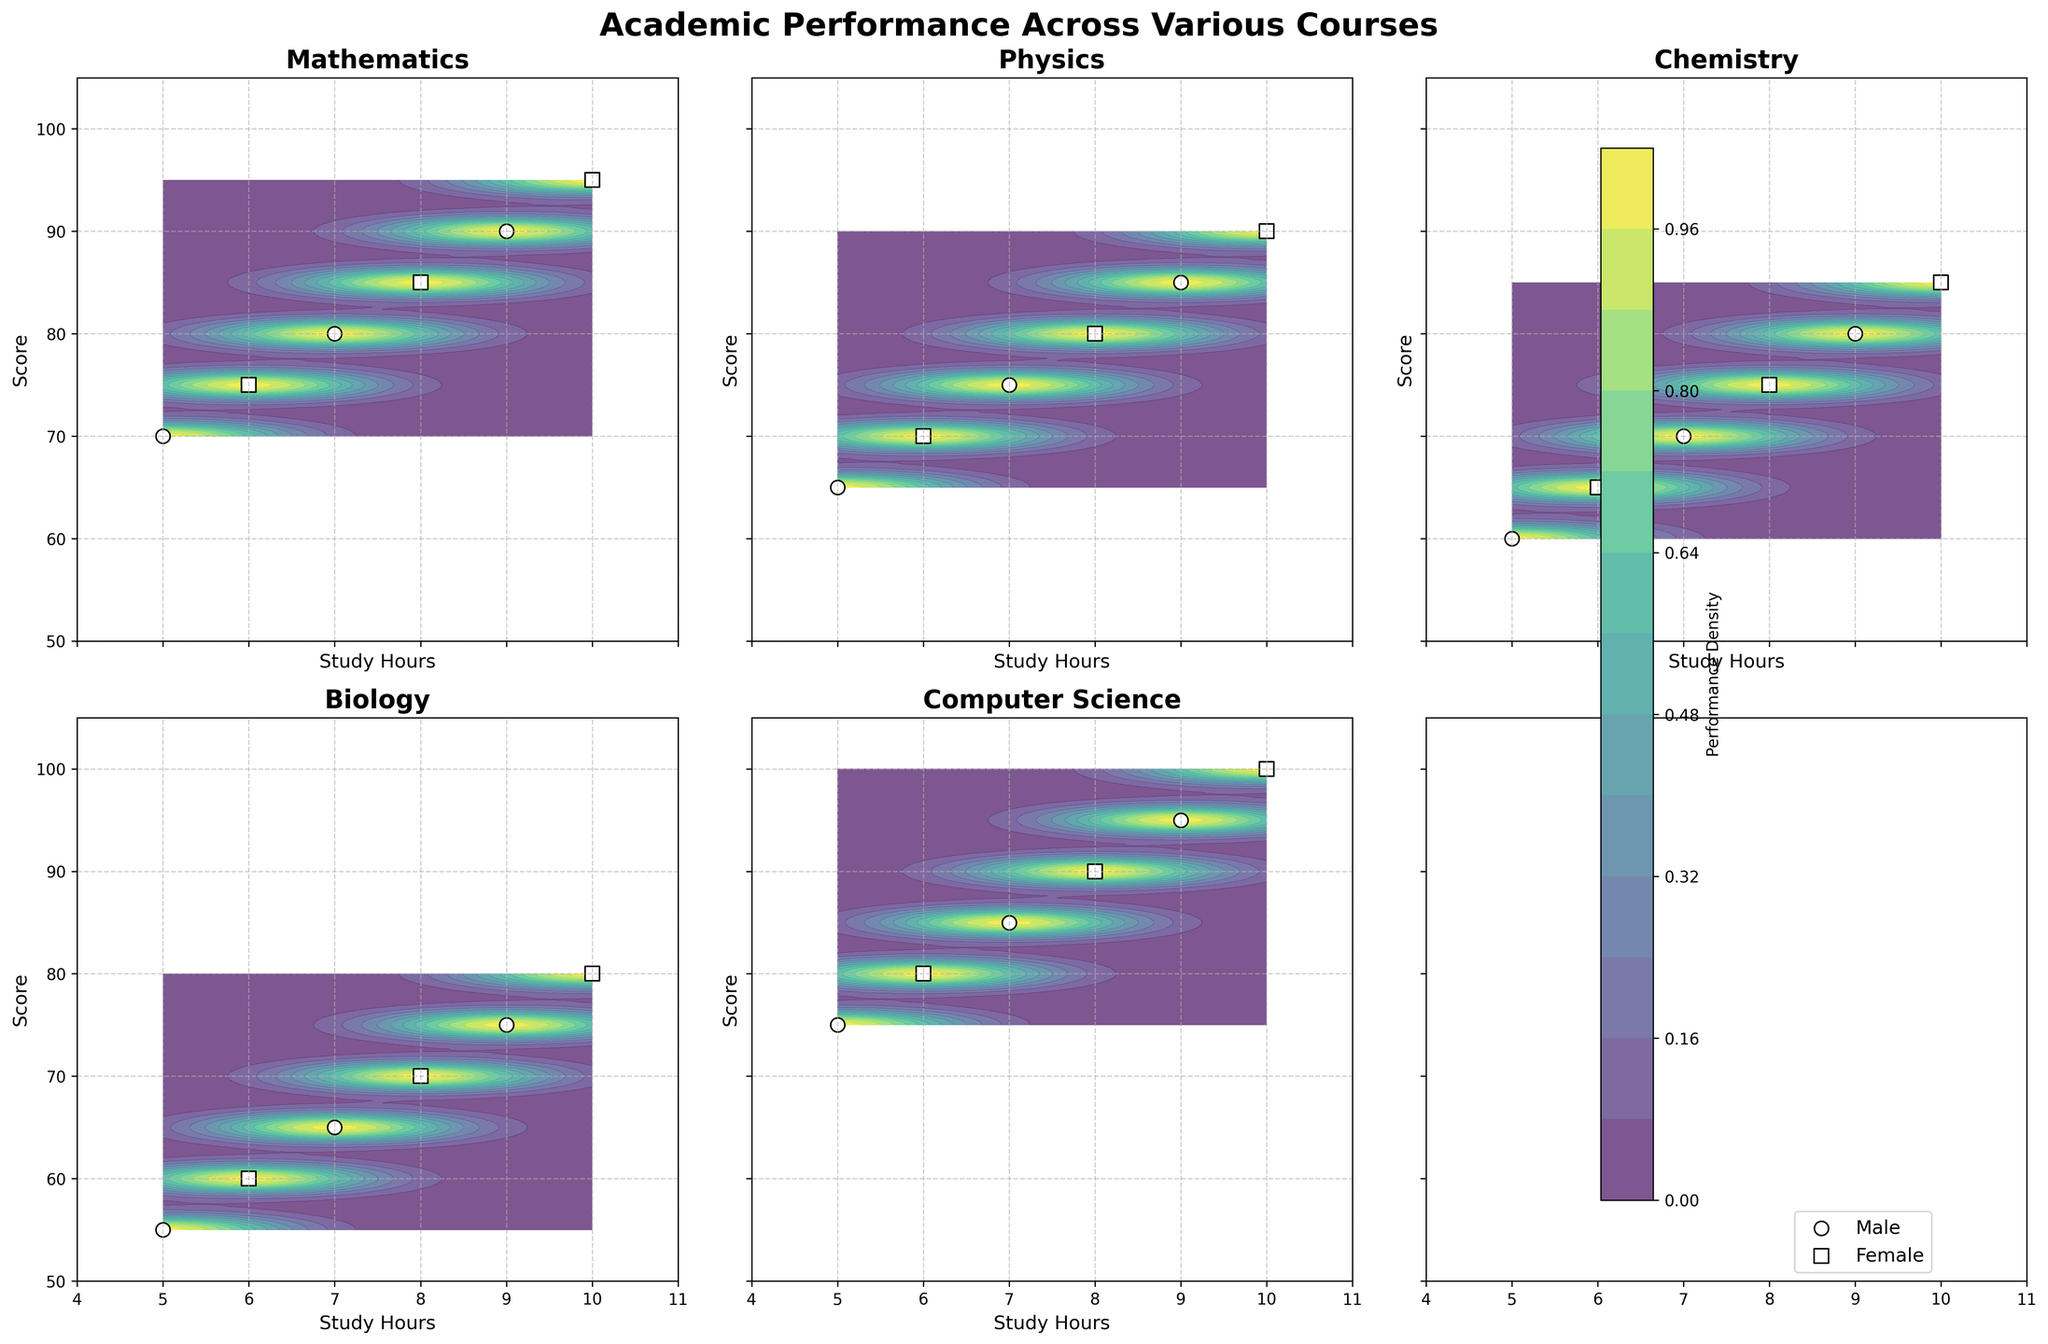What is the title of the figure? The title is displayed at the top of the figure in a large, bold font. It reads "Academic Performance Across Various Courses."
Answer: Academic Performance Across Various Courses Which course shows the highest score for the female group? Looking at the subplots, the Computer Science course shows the highest score for the female group, which is 100.
Answer: Computer Science How does the performance of males and females in Mathematics compare? In Mathematics, females consistently have higher scores than males for the same study hours. Each point for females is above the male counterpart.
Answer: Females have higher scores What is the range of study hours considered in these courses? The x-axis of each subplot ranges from 4 to 11 hours of study.
Answer: 4 to 11 hours Which course has the lowest score, and which gender does it belong to? In the Biology subplot, males have the lowest score of 55.
Answer: Biology, Male On average, do males or females perform better across all courses? Females perform better on average since, in each subplot, their scores are higher for the same study hours compared to males.
Answer: Females What is the common trend observed in scores with increasing study hours across all courses? In all courses, both males and females show a trend of increasing scores as study hours increase.
Answer: Scores increase with study hours Which subplot represents the highest performance density? The Computer Science subplot shows the highest performance density since its contour lines are more concentrated in the higher score range.
Answer: Computer Science How do the contour lines help in identifying performance density? Contour lines represent performance density; regions with closely spaced lines indicate higher density, suggesting where most scores concentrate.
Answer: Regions with closely spaced lines indicate higher density What is the color scheme used to represent performance density, and what does it indicate? A viridis color map is used, where lighter colors indicate higher performance densities and darker colors indicate lower densities.
Answer: Lighter colors for higher density, darker for lower density 